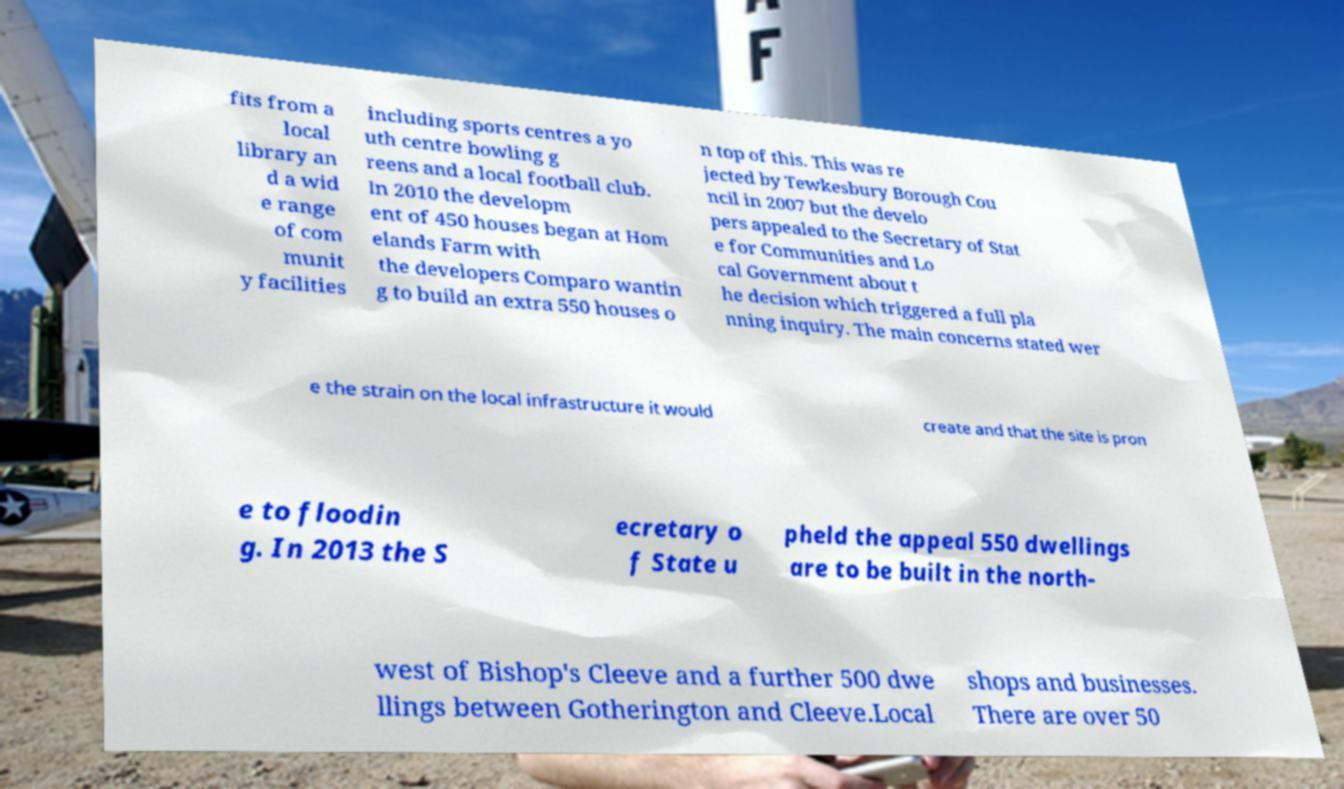Please read and relay the text visible in this image. What does it say? fits from a local library an d a wid e range of com munit y facilities including sports centres a yo uth centre bowling g reens and a local football club. In 2010 the developm ent of 450 houses began at Hom elands Farm with the developers Comparo wantin g to build an extra 550 houses o n top of this. This was re jected by Tewkesbury Borough Cou ncil in 2007 but the develo pers appealed to the Secretary of Stat e for Communities and Lo cal Government about t he decision which triggered a full pla nning inquiry. The main concerns stated wer e the strain on the local infrastructure it would create and that the site is pron e to floodin g. In 2013 the S ecretary o f State u pheld the appeal 550 dwellings are to be built in the north- west of Bishop's Cleeve and a further 500 dwe llings between Gotherington and Cleeve.Local shops and businesses. There are over 50 